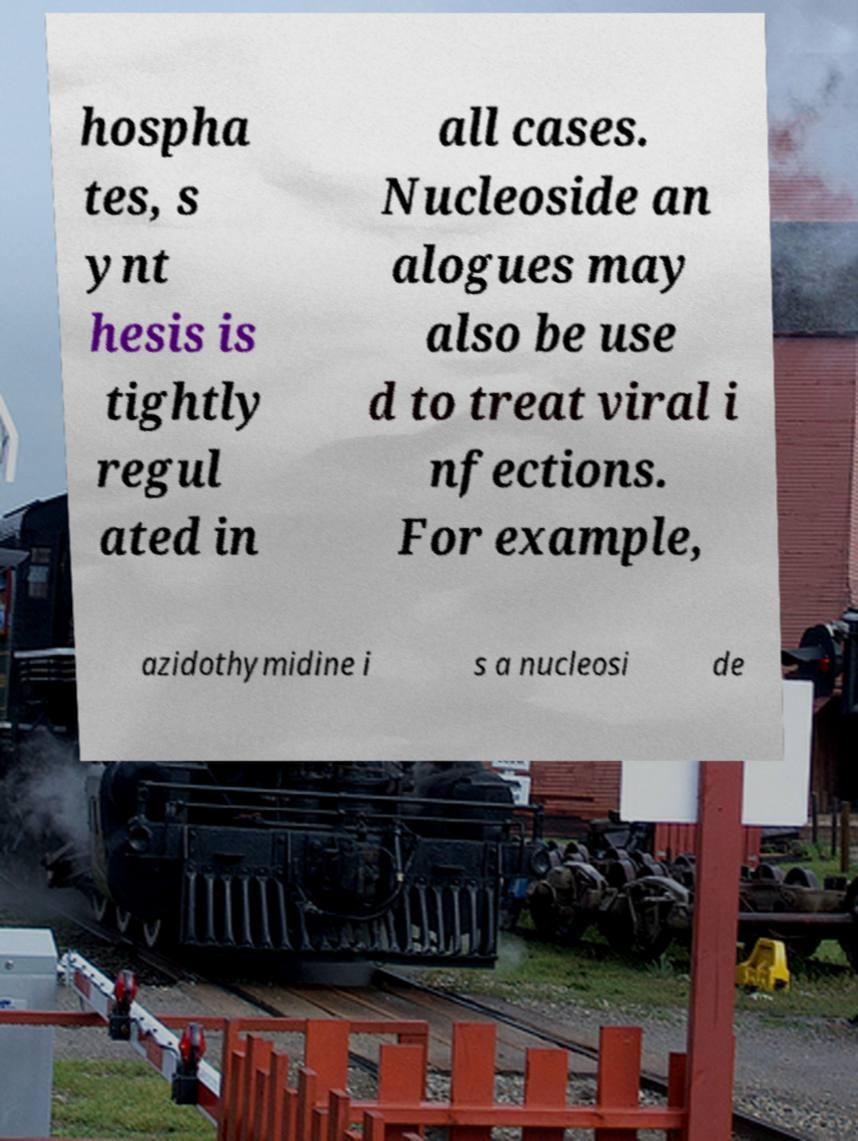I need the written content from this picture converted into text. Can you do that? hospha tes, s ynt hesis is tightly regul ated in all cases. Nucleoside an alogues may also be use d to treat viral i nfections. For example, azidothymidine i s a nucleosi de 